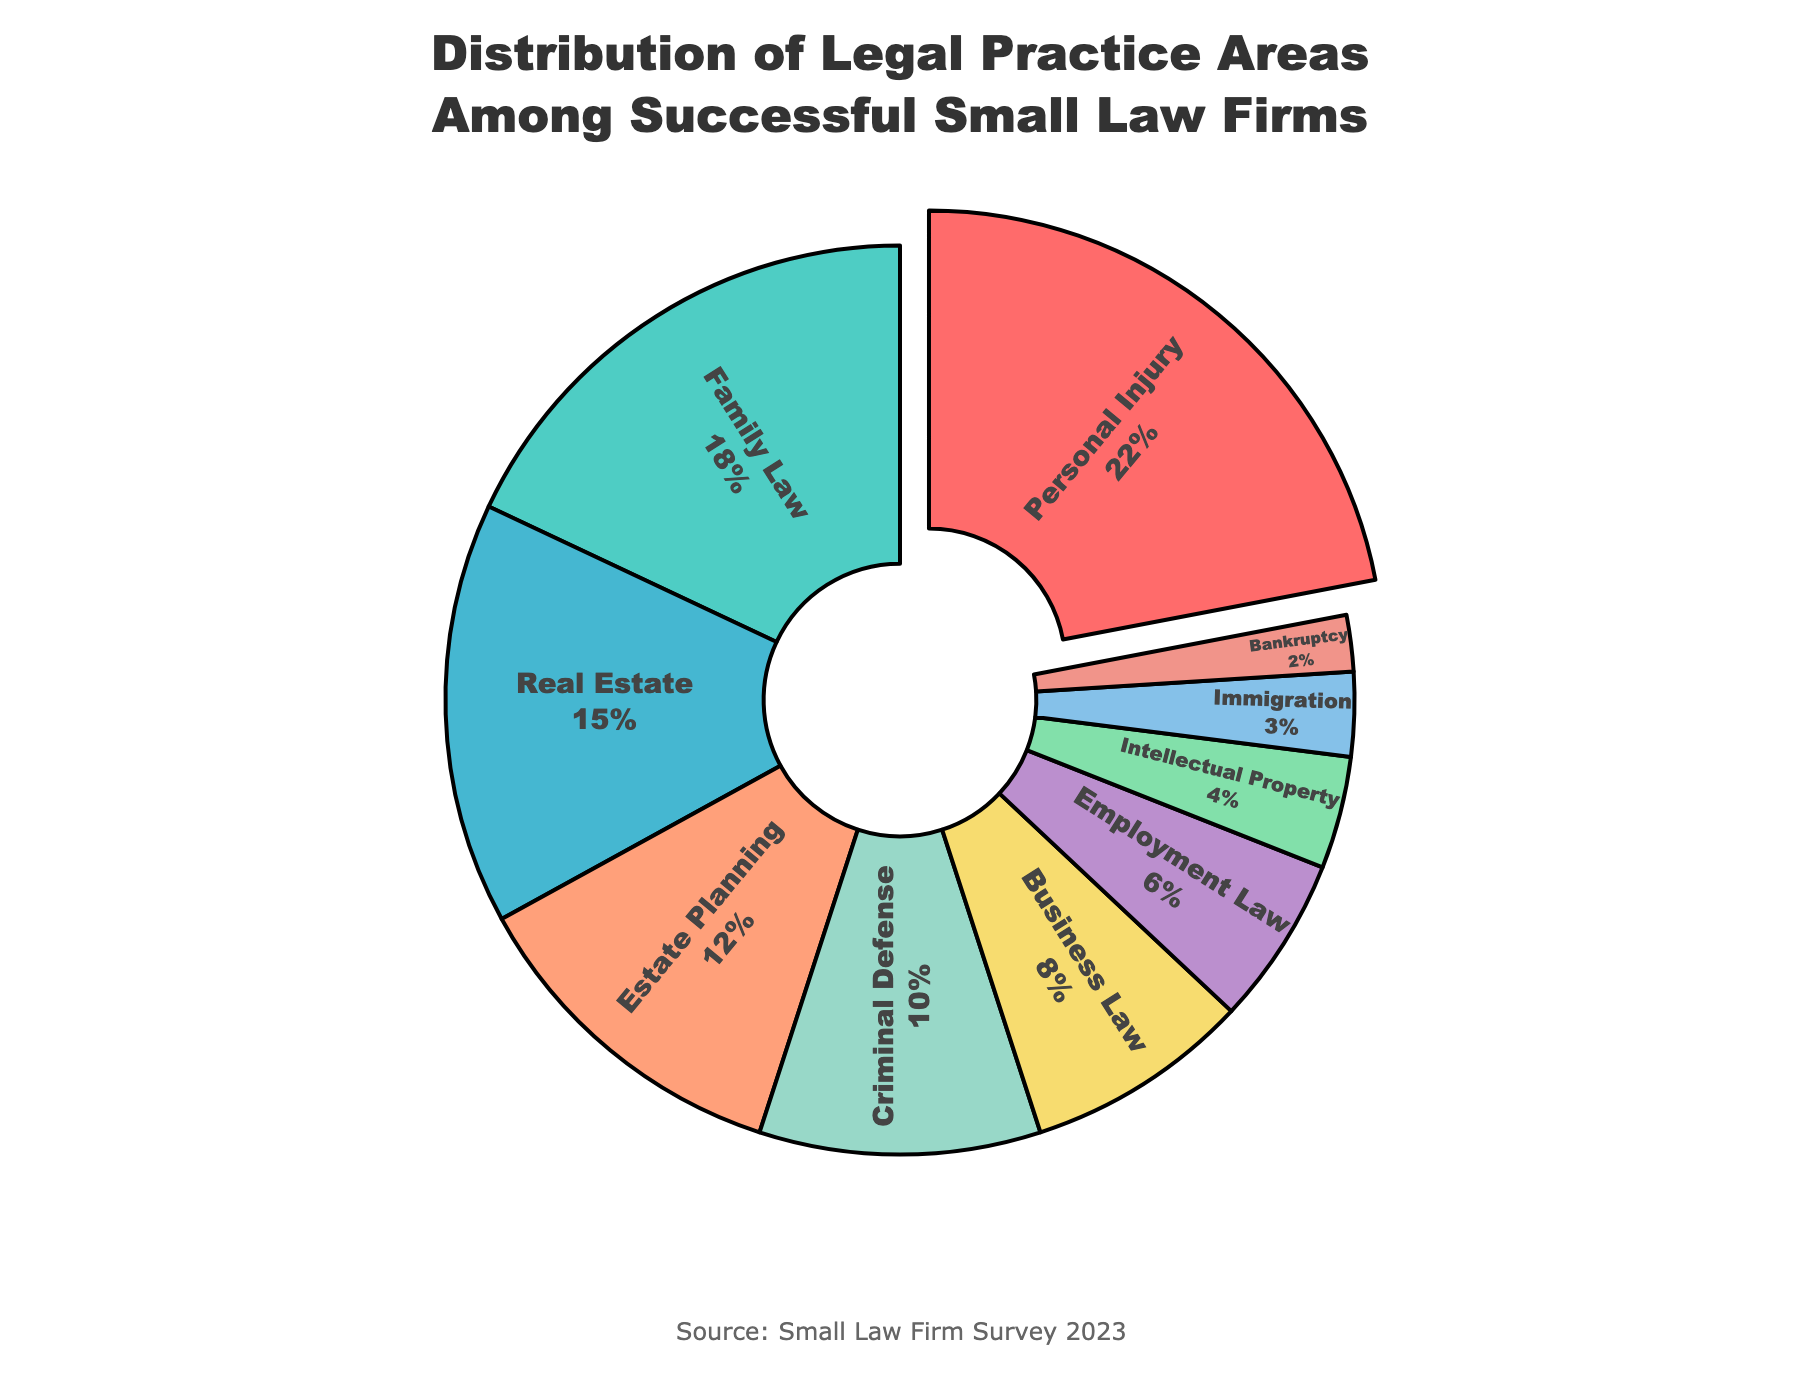what is the largest practice area among successful small law firms? The largest practice area can be identified by looking at the segment with the highest percentage. The segment labeled "Personal Injury" has the largest percentage of 22%.
Answer: Personal Injury What percentage of successful small law firms focus on Family Law? Locate the segment labeled "Family Law" and refer to its percentage. The percentage for Family Law is 18%.
Answer: 18% What is the combined percentage of Real Estate and Estate Planning? Add the percentages of Real Estate and Estate Planning. Real Estate is 15% and Estate Planning is 12%, so 15% + 12% = 27%.
Answer: 27% How much more prevalent is Business Law compared to Immigration? Subtract the percentage of Immigration from the percentage of Business Law. Business Law is 8% and Immigration is 3%, so 8% - 3% = 5%.
Answer: 5% Which practice area occupies the smallest segment in the pie chart? The smallest segment can be identified by finding the segment with the lowest percentage. The segment labeled "Bankruptcy" has the smallest percentage of 2%.
Answer: Bankruptcy What is the total percentage covered by Criminal Defense, Business Law, and Employment Law? Add the percentages of Criminal Defense, Business Law, and Employment Law. Criminal Defense is 10%, Business Law is 8%, and Employment Law is 6%. So, 10% + 8% + 6% = 24%.
Answer: 24% Which practice areas together form more than 40% of successful small law firms? Identify practice areas and add their percentages sequentially until the sum exceeds 40%. Adding Personal Injury (22%) and Family Law (18%) yields 40% exactly. Including any additional area like Real Estate (15%) will exceed 40%.
Answer: Personal Injury, Family Law How does the percentage of Estate Planning compare to that of Criminal Defense? Compare the percentages directly. Estate Planning is 12% and Criminal Defense is 10%. Estate Planning is 2% more than Criminal Defense.
Answer: 2% What is the cumulative percentage of the three least common practice areas? Identify the three segments with the smallest percentages: Bankruptcy (2%), Immigration (3%), and Intellectual Property (4%). Add these percentages: 2% + 3% + 4% = 9%.
Answer: 9% Which practice area appears in cyan color in the pie chart? Locate the segment colored cyan. The cyan color corresponds to the segment labeled "Family Law," which is 18%.
Answer: Family Law 